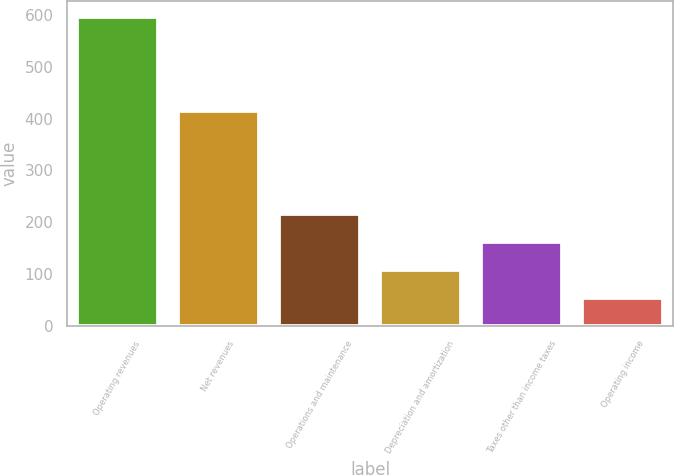<chart> <loc_0><loc_0><loc_500><loc_500><bar_chart><fcel>Operating revenues<fcel>Net revenues<fcel>Operations and maintenance<fcel>Depreciation and amortization<fcel>Taxes other than income taxes<fcel>Operating income<nl><fcel>596<fcel>415<fcel>216.6<fcel>108.2<fcel>162.4<fcel>54<nl></chart> 